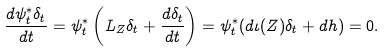<formula> <loc_0><loc_0><loc_500><loc_500>\frac { d \psi _ { t } ^ { * } \delta _ { t } } { d t } = \psi _ { t } ^ { * } \left ( L _ { Z } \delta _ { t } + \frac { d \delta _ { t } } { d t } \right ) = \psi _ { t } ^ { * } ( d \iota ( Z ) \delta _ { t } + d h ) = 0 .</formula> 